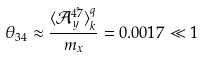Convert formula to latex. <formula><loc_0><loc_0><loc_500><loc_500>\theta _ { 3 4 } \approx \frac { \langle \mathcal { A } _ { y } ^ { \hat { 4 7 } } \rangle ^ { q } _ { k } } { m _ { x } } = 0 . 0 0 1 7 \ll 1</formula> 